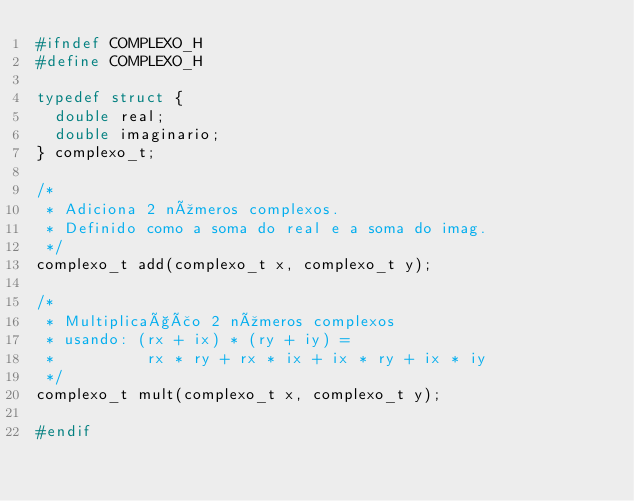<code> <loc_0><loc_0><loc_500><loc_500><_C_>#ifndef COMPLEXO_H
#define COMPLEXO_H

typedef struct {
  double real;
  double imaginario;
} complexo_t;

/*
 * Adiciona 2 números complexos.
 * Definido como a soma do real e a soma do imag.
 */
complexo_t add(complexo_t x, complexo_t y);

/*
 * Multiplicação 2 números complexos
 * usando: (rx + ix) * (ry + iy) =
 *          rx * ry + rx * ix + ix * ry + ix * iy
 */
complexo_t mult(complexo_t x, complexo_t y);

#endif
</code> 